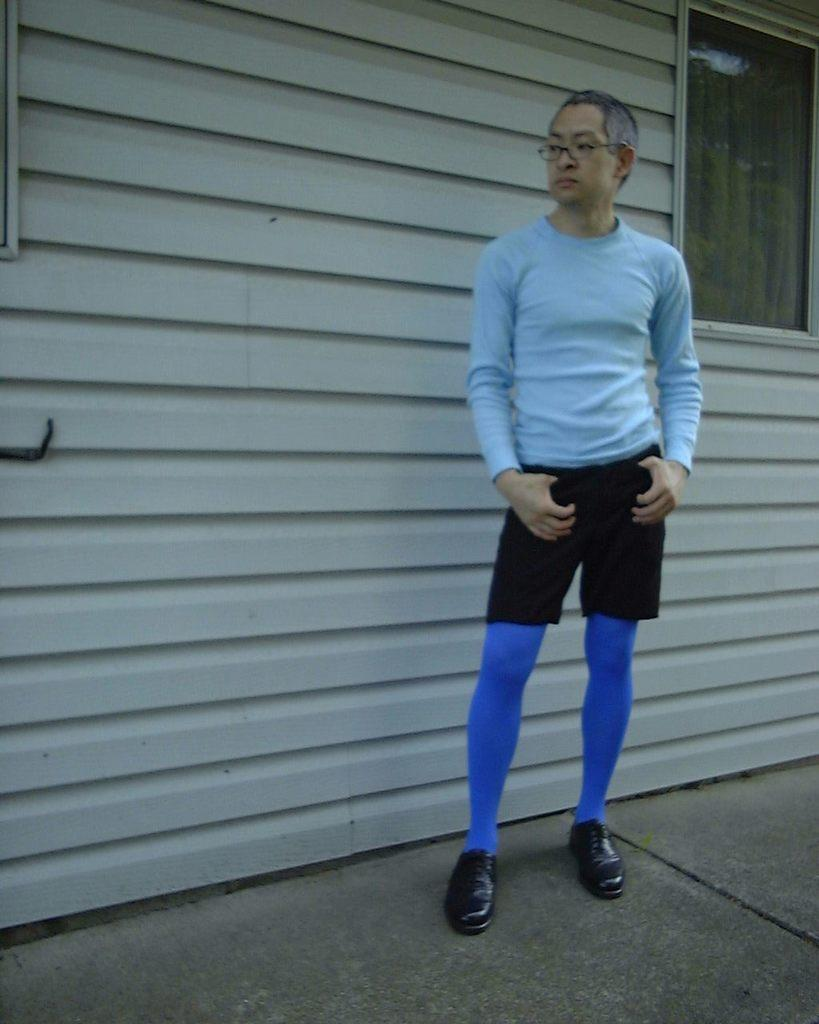What is the main subject of the image? There is a person standing in the center of the image. Can you describe the person's appearance? The person is wearing glasses. What can be seen in the background of the image? There is a window in the background of the image. Where is the window located? The window is on a wall. What is visible at the bottom of the image? There is a road at the bottom of the image. What type of spark can be seen coming from the person's glasses in the image? There is no spark visible coming from the person's glasses in the image. What type of farm can be seen in the background of the image? There is no farm visible in the background of the image; it features a window on a wall. 